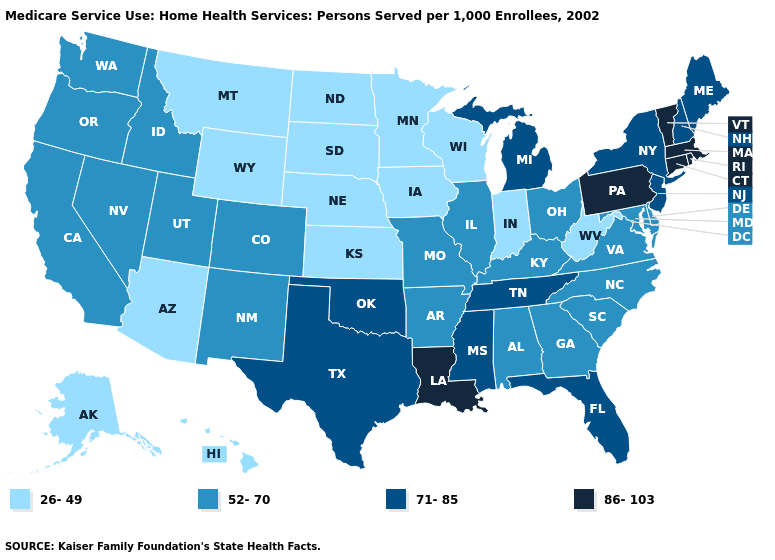Among the states that border Wyoming , does Montana have the lowest value?
Concise answer only. Yes. Does Michigan have the highest value in the MidWest?
Concise answer only. Yes. What is the value of Connecticut?
Concise answer only. 86-103. Does Colorado have the same value as North Carolina?
Concise answer only. Yes. Does New Mexico have the same value as Alabama?
Short answer required. Yes. Which states have the lowest value in the West?
Answer briefly. Alaska, Arizona, Hawaii, Montana, Wyoming. How many symbols are there in the legend?
Keep it brief. 4. What is the value of Hawaii?
Short answer required. 26-49. What is the lowest value in states that border Arkansas?
Quick response, please. 52-70. What is the lowest value in the USA?
Answer briefly. 26-49. What is the highest value in the USA?
Concise answer only. 86-103. Name the states that have a value in the range 26-49?
Keep it brief. Alaska, Arizona, Hawaii, Indiana, Iowa, Kansas, Minnesota, Montana, Nebraska, North Dakota, South Dakota, West Virginia, Wisconsin, Wyoming. Name the states that have a value in the range 71-85?
Keep it brief. Florida, Maine, Michigan, Mississippi, New Hampshire, New Jersey, New York, Oklahoma, Tennessee, Texas. Among the states that border Connecticut , does New York have the highest value?
Give a very brief answer. No. 